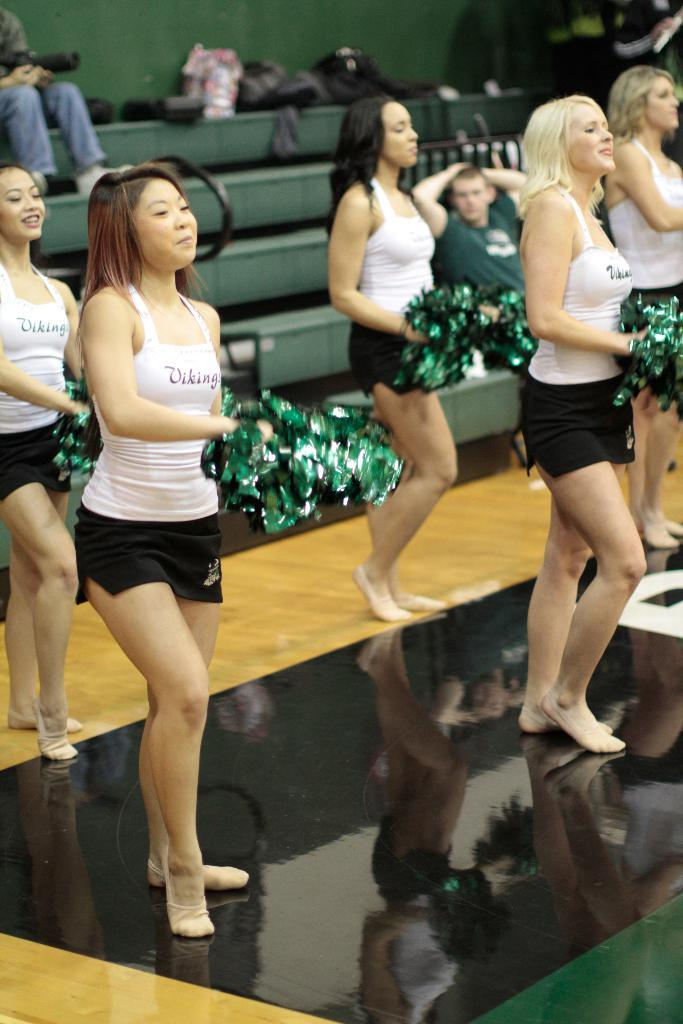What is happening in the image involving the ladies? The ladies are dancing in the image. What else can be seen in the image besides the dancing ladies? There are stairs visible in the image, and there are persons sitting on the stairs. How many sheep are present in the image? There are no sheep present in the image. What type of desk can be seen in the image? There is no desk present in the image. 